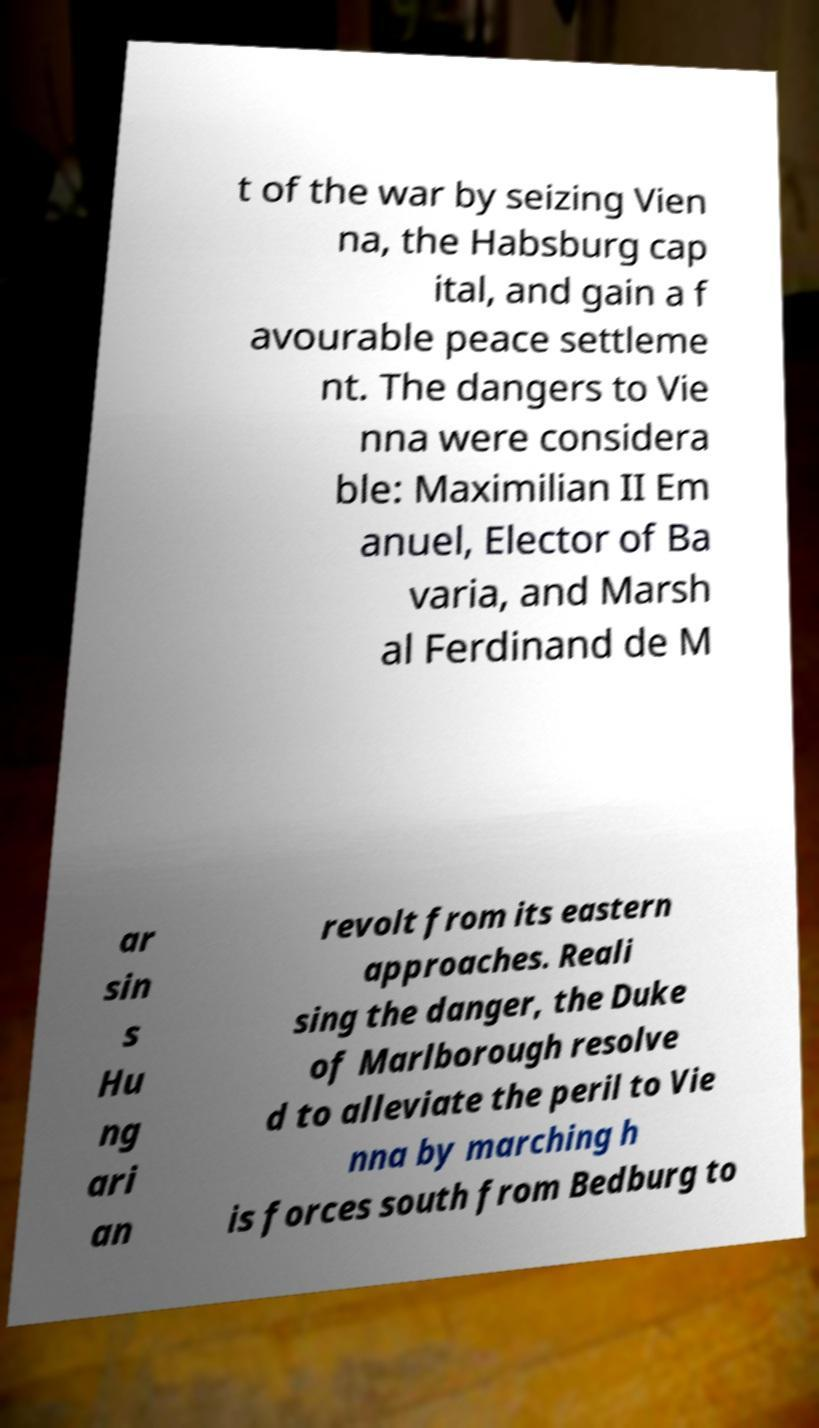What messages or text are displayed in this image? I need them in a readable, typed format. t of the war by seizing Vien na, the Habsburg cap ital, and gain a f avourable peace settleme nt. The dangers to Vie nna were considera ble: Maximilian II Em anuel, Elector of Ba varia, and Marsh al Ferdinand de M ar sin s Hu ng ari an revolt from its eastern approaches. Reali sing the danger, the Duke of Marlborough resolve d to alleviate the peril to Vie nna by marching h is forces south from Bedburg to 